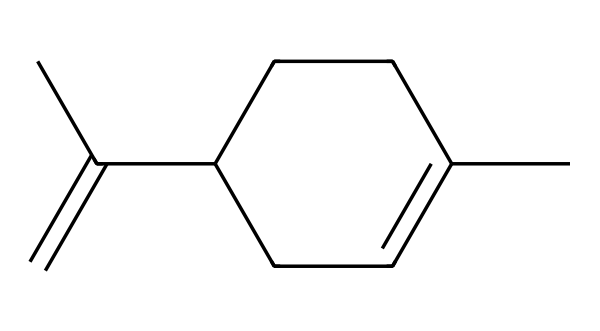What is the molecular formula of limonene? To determine the molecular formula, count the number of carbon (C) and hydrogen (H) atoms from the SMILES representation. There are 10 carbon atoms and 16 hydrogen atoms. Therefore, the molecular formula is C10H16.
Answer: C10H16 How many rings are present in the structure of limonene? From the SMILES representation, analyze the structure. There is one cycloalkane ring present (the C1=CCC(CC1) indicates a cyclic structure), and there are no other rings.
Answer: 1 What type of compound is limonene? Recognize that limonene is a type of terpene, specifically a monoterpene, which is characterized by its structure of 10 carbon atoms. It is formed from two isoprene units.
Answer: terpene Identify the type of hybridization around the sp2 carbon atom in limonene. In the structure of limonene, the carbon atoms involved in the double bonds (C=C) exhibit sp2 hybridization. The presence of a double bond indicates that two of the substituents are in the same plane, characteristic of sp2 hybridization.
Answer: sp2 What functional group is indicated by the double bond in limonene? The double bond in limonene correlates to the presence of alkenes, which contain carbon-carbon double bonds. This is part of the defining structural characteristic of limonene.
Answer: alkene How does the structure of limonene contribute to its citrus aroma? The specific arrangement of double bonds and the cyclic structure creates a unique electronic environment affecting the aroma profile. This molecular structure leads to the characteristic citrus scent associated with limonene.
Answer: structure 